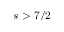<formula> <loc_0><loc_0><loc_500><loc_500>s > 7 / 2</formula> 